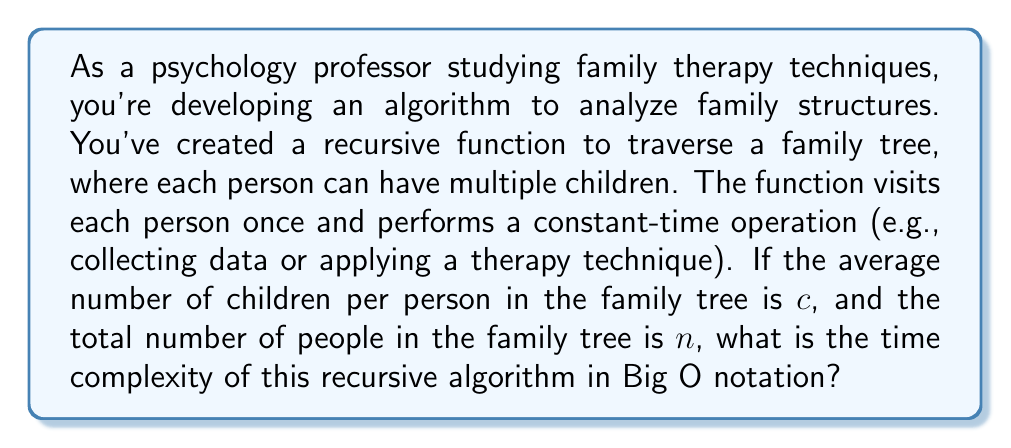What is the answer to this math problem? To analyze the time complexity of this recursive algorithm, let's break it down step-by-step:

1) First, we need to understand the structure of the problem. We have a tree-like structure (the family tree) where each node (person) can have multiple children.

2) The recursive function visits each person once and performs a constant-time operation. This means that the time spent on each individual is O(1).

3) The total time complexity will depend on how many times this constant-time operation is performed, which is equal to the number of people in the family tree, n.

4) In a tree traversal, the recursive function is called once for each node in the tree. Therefore, the function will be called n times in total.

5) The branching factor of the tree (average number of children per person) doesn't affect the number of nodes visited, but it does affect the depth of the recursion stack. However, this doesn't change the overall time complexity in this case.

6) Since we perform a constant-time operation n times (once for each person in the family tree), the overall time complexity is O(n).

7) It's worth noting that while the space complexity would be affected by the average number of children (c) due to the recursion stack, the question asks specifically about time complexity.

Therefore, regardless of the average number of children per person (c), the time complexity remains linear with respect to the total number of people in the family tree (n).
Answer: O(n) 